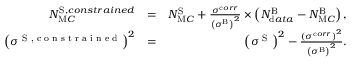<formula> <loc_0><loc_0><loc_500><loc_500>\begin{array} { r l r } { N _ { M C } ^ { S , c o n s t r a i n e d } } & { = } & { N _ { M C } ^ { S } + \frac { { \sigma } ^ { c o r r } } { \left ( { \sigma } ^ { B } \right ) ^ { 2 } } \times \left ( N _ { d a t a } ^ { B } - N _ { M C } ^ { B } \right ) , } \\ { \left ( { \sigma } ^ { S , c o n s t r a i n e d } \right ) ^ { 2 } } & { = } & { \left ( { \sigma } ^ { S } \right ) ^ { 2 } - \frac { \left ( { \sigma } ^ { c o r r } \right ) ^ { 2 } } { \left ( { \sigma } ^ { B } \right ) ^ { 2 } } . } \end{array}</formula> 